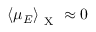<formula> <loc_0><loc_0><loc_500><loc_500>\left < \mu _ { E } \right > _ { X } \approx 0</formula> 